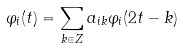<formula> <loc_0><loc_0><loc_500><loc_500>\varphi _ { i } ( t ) = \sum _ { k \in { Z } } a _ { i k } \varphi _ { i } ( 2 t - k )</formula> 